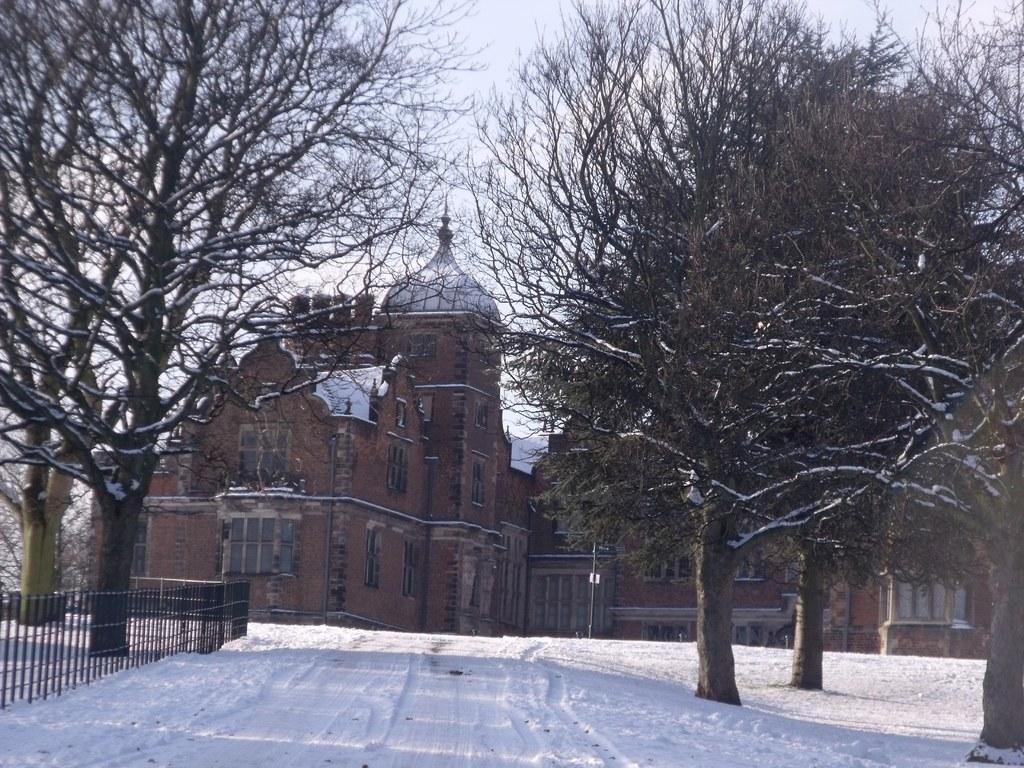Describe this image in one or two sentences. In this image we can see a building with windows on it. To the left side, we can see a fence. In the background, we can see a group of trees and sky. 